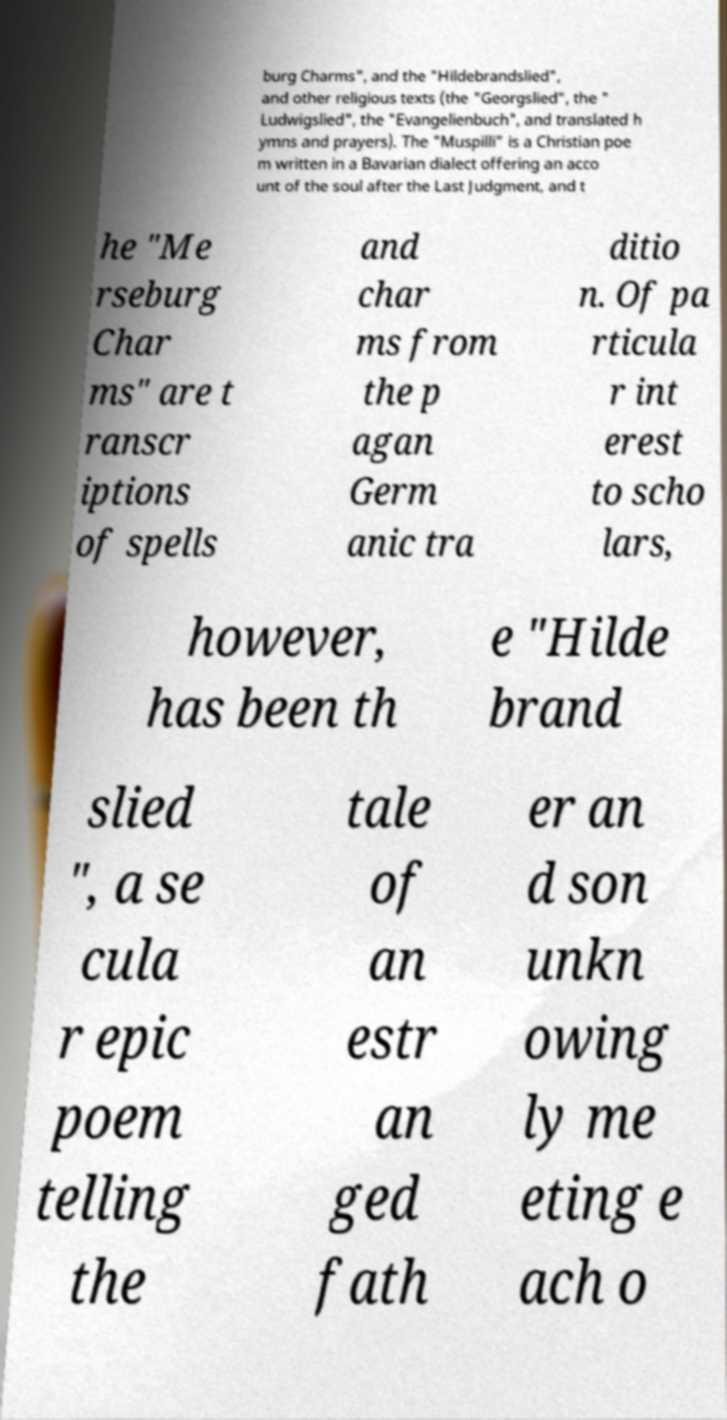Can you accurately transcribe the text from the provided image for me? burg Charms", and the "Hildebrandslied", and other religious texts (the "Georgslied", the " Ludwigslied", the "Evangelienbuch", and translated h ymns and prayers). The "Muspilli" is a Christian poe m written in a Bavarian dialect offering an acco unt of the soul after the Last Judgment, and t he "Me rseburg Char ms" are t ranscr iptions of spells and char ms from the p agan Germ anic tra ditio n. Of pa rticula r int erest to scho lars, however, has been th e "Hilde brand slied ", a se cula r epic poem telling the tale of an estr an ged fath er an d son unkn owing ly me eting e ach o 